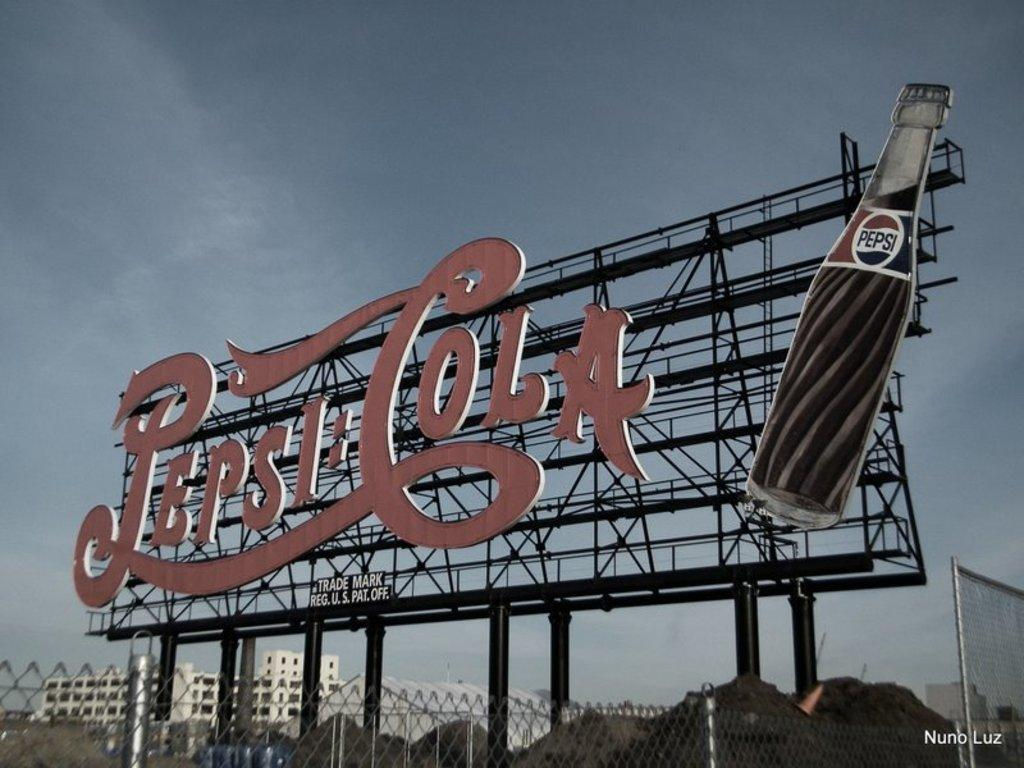<image>
Create a compact narrative representing the image presented. A Pepsi-Cola billboard has been trademarked by the Reg. U.S. patent office. 